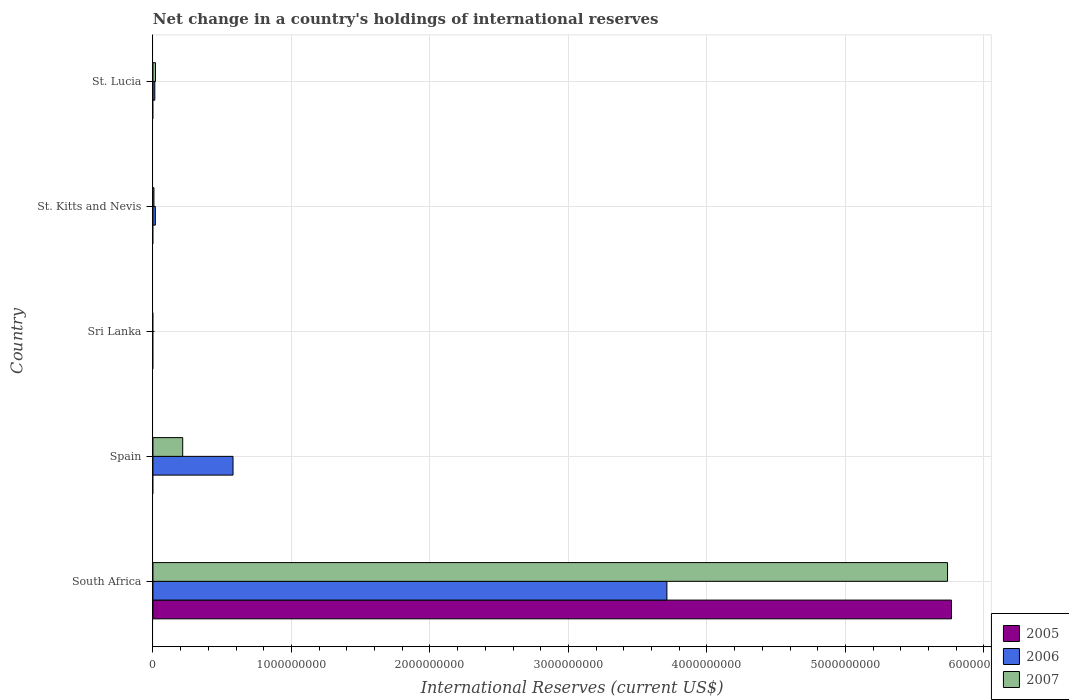How many different coloured bars are there?
Make the answer very short. 3. Are the number of bars per tick equal to the number of legend labels?
Keep it short and to the point. No. What is the label of the 5th group of bars from the top?
Ensure brevity in your answer.  South Africa. In how many cases, is the number of bars for a given country not equal to the number of legend labels?
Offer a terse response. 4. What is the international reserves in 2005 in St. Lucia?
Give a very brief answer. 0. Across all countries, what is the maximum international reserves in 2006?
Provide a succinct answer. 3.71e+09. In which country was the international reserves in 2006 maximum?
Provide a short and direct response. South Africa. What is the total international reserves in 2007 in the graph?
Offer a very short reply. 5.98e+09. What is the difference between the international reserves in 2006 in South Africa and that in St. Lucia?
Give a very brief answer. 3.70e+09. What is the difference between the international reserves in 2006 in South Africa and the international reserves in 2005 in St. Lucia?
Provide a short and direct response. 3.71e+09. What is the average international reserves in 2007 per country?
Your answer should be very brief. 1.20e+09. What is the difference between the international reserves in 2007 and international reserves in 2006 in South Africa?
Your response must be concise. 2.03e+09. In how many countries, is the international reserves in 2007 greater than 800000000 US$?
Offer a very short reply. 1. What is the ratio of the international reserves in 2006 in South Africa to that in St. Kitts and Nevis?
Your answer should be compact. 216.4. Is the difference between the international reserves in 2007 in South Africa and St. Kitts and Nevis greater than the difference between the international reserves in 2006 in South Africa and St. Kitts and Nevis?
Give a very brief answer. Yes. What is the difference between the highest and the second highest international reserves in 2006?
Your response must be concise. 3.13e+09. What is the difference between the highest and the lowest international reserves in 2006?
Make the answer very short. 3.71e+09. Is it the case that in every country, the sum of the international reserves in 2005 and international reserves in 2007 is greater than the international reserves in 2006?
Your response must be concise. No. Are all the bars in the graph horizontal?
Your answer should be very brief. Yes. How many countries are there in the graph?
Offer a terse response. 5. Are the values on the major ticks of X-axis written in scientific E-notation?
Provide a short and direct response. No. Where does the legend appear in the graph?
Give a very brief answer. Bottom right. How many legend labels are there?
Your answer should be compact. 3. How are the legend labels stacked?
Keep it short and to the point. Vertical. What is the title of the graph?
Provide a succinct answer. Net change in a country's holdings of international reserves. What is the label or title of the X-axis?
Your answer should be compact. International Reserves (current US$). What is the International Reserves (current US$) of 2005 in South Africa?
Your answer should be compact. 5.77e+09. What is the International Reserves (current US$) in 2006 in South Africa?
Make the answer very short. 3.71e+09. What is the International Reserves (current US$) of 2007 in South Africa?
Offer a very short reply. 5.74e+09. What is the International Reserves (current US$) of 2006 in Spain?
Provide a succinct answer. 5.78e+08. What is the International Reserves (current US$) of 2007 in Spain?
Your answer should be compact. 2.15e+08. What is the International Reserves (current US$) in 2006 in Sri Lanka?
Your answer should be compact. 0. What is the International Reserves (current US$) of 2007 in Sri Lanka?
Ensure brevity in your answer.  0. What is the International Reserves (current US$) of 2005 in St. Kitts and Nevis?
Make the answer very short. 0. What is the International Reserves (current US$) of 2006 in St. Kitts and Nevis?
Keep it short and to the point. 1.71e+07. What is the International Reserves (current US$) of 2007 in St. Kitts and Nevis?
Ensure brevity in your answer.  7.18e+06. What is the International Reserves (current US$) in 2006 in St. Lucia?
Offer a terse response. 1.35e+07. What is the International Reserves (current US$) in 2007 in St. Lucia?
Make the answer very short. 1.86e+07. Across all countries, what is the maximum International Reserves (current US$) of 2005?
Your response must be concise. 5.77e+09. Across all countries, what is the maximum International Reserves (current US$) in 2006?
Make the answer very short. 3.71e+09. Across all countries, what is the maximum International Reserves (current US$) of 2007?
Offer a very short reply. 5.74e+09. Across all countries, what is the minimum International Reserves (current US$) in 2005?
Offer a terse response. 0. What is the total International Reserves (current US$) of 2005 in the graph?
Provide a short and direct response. 5.77e+09. What is the total International Reserves (current US$) in 2006 in the graph?
Your response must be concise. 4.32e+09. What is the total International Reserves (current US$) in 2007 in the graph?
Give a very brief answer. 5.98e+09. What is the difference between the International Reserves (current US$) of 2006 in South Africa and that in Spain?
Keep it short and to the point. 3.13e+09. What is the difference between the International Reserves (current US$) of 2007 in South Africa and that in Spain?
Ensure brevity in your answer.  5.52e+09. What is the difference between the International Reserves (current US$) in 2006 in South Africa and that in St. Kitts and Nevis?
Your answer should be compact. 3.69e+09. What is the difference between the International Reserves (current US$) in 2007 in South Africa and that in St. Kitts and Nevis?
Provide a short and direct response. 5.73e+09. What is the difference between the International Reserves (current US$) in 2006 in South Africa and that in St. Lucia?
Your answer should be compact. 3.70e+09. What is the difference between the International Reserves (current US$) in 2007 in South Africa and that in St. Lucia?
Your answer should be very brief. 5.72e+09. What is the difference between the International Reserves (current US$) of 2006 in Spain and that in St. Kitts and Nevis?
Offer a very short reply. 5.61e+08. What is the difference between the International Reserves (current US$) of 2007 in Spain and that in St. Kitts and Nevis?
Your answer should be compact. 2.08e+08. What is the difference between the International Reserves (current US$) of 2006 in Spain and that in St. Lucia?
Your response must be concise. 5.65e+08. What is the difference between the International Reserves (current US$) in 2007 in Spain and that in St. Lucia?
Make the answer very short. 1.96e+08. What is the difference between the International Reserves (current US$) of 2006 in St. Kitts and Nevis and that in St. Lucia?
Your answer should be very brief. 3.67e+06. What is the difference between the International Reserves (current US$) of 2007 in St. Kitts and Nevis and that in St. Lucia?
Offer a very short reply. -1.14e+07. What is the difference between the International Reserves (current US$) of 2005 in South Africa and the International Reserves (current US$) of 2006 in Spain?
Keep it short and to the point. 5.19e+09. What is the difference between the International Reserves (current US$) of 2005 in South Africa and the International Reserves (current US$) of 2007 in Spain?
Keep it short and to the point. 5.55e+09. What is the difference between the International Reserves (current US$) in 2006 in South Africa and the International Reserves (current US$) in 2007 in Spain?
Offer a very short reply. 3.50e+09. What is the difference between the International Reserves (current US$) in 2005 in South Africa and the International Reserves (current US$) in 2006 in St. Kitts and Nevis?
Provide a short and direct response. 5.75e+09. What is the difference between the International Reserves (current US$) of 2005 in South Africa and the International Reserves (current US$) of 2007 in St. Kitts and Nevis?
Ensure brevity in your answer.  5.76e+09. What is the difference between the International Reserves (current US$) of 2006 in South Africa and the International Reserves (current US$) of 2007 in St. Kitts and Nevis?
Your answer should be compact. 3.70e+09. What is the difference between the International Reserves (current US$) of 2005 in South Africa and the International Reserves (current US$) of 2006 in St. Lucia?
Provide a short and direct response. 5.75e+09. What is the difference between the International Reserves (current US$) in 2005 in South Africa and the International Reserves (current US$) in 2007 in St. Lucia?
Keep it short and to the point. 5.75e+09. What is the difference between the International Reserves (current US$) of 2006 in South Africa and the International Reserves (current US$) of 2007 in St. Lucia?
Your answer should be compact. 3.69e+09. What is the difference between the International Reserves (current US$) of 2006 in Spain and the International Reserves (current US$) of 2007 in St. Kitts and Nevis?
Your response must be concise. 5.71e+08. What is the difference between the International Reserves (current US$) of 2006 in Spain and the International Reserves (current US$) of 2007 in St. Lucia?
Give a very brief answer. 5.60e+08. What is the difference between the International Reserves (current US$) in 2006 in St. Kitts and Nevis and the International Reserves (current US$) in 2007 in St. Lucia?
Ensure brevity in your answer.  -1.43e+06. What is the average International Reserves (current US$) of 2005 per country?
Offer a very short reply. 1.15e+09. What is the average International Reserves (current US$) of 2006 per country?
Provide a succinct answer. 8.64e+08. What is the average International Reserves (current US$) in 2007 per country?
Ensure brevity in your answer.  1.20e+09. What is the difference between the International Reserves (current US$) in 2005 and International Reserves (current US$) in 2006 in South Africa?
Keep it short and to the point. 2.05e+09. What is the difference between the International Reserves (current US$) of 2005 and International Reserves (current US$) of 2007 in South Africa?
Provide a short and direct response. 2.86e+07. What is the difference between the International Reserves (current US$) of 2006 and International Reserves (current US$) of 2007 in South Africa?
Make the answer very short. -2.03e+09. What is the difference between the International Reserves (current US$) of 2006 and International Reserves (current US$) of 2007 in Spain?
Make the answer very short. 3.63e+08. What is the difference between the International Reserves (current US$) of 2006 and International Reserves (current US$) of 2007 in St. Kitts and Nevis?
Offer a terse response. 9.97e+06. What is the difference between the International Reserves (current US$) of 2006 and International Reserves (current US$) of 2007 in St. Lucia?
Your response must be concise. -5.10e+06. What is the ratio of the International Reserves (current US$) of 2006 in South Africa to that in Spain?
Keep it short and to the point. 6.42. What is the ratio of the International Reserves (current US$) of 2007 in South Africa to that in Spain?
Offer a very short reply. 26.7. What is the ratio of the International Reserves (current US$) of 2006 in South Africa to that in St. Kitts and Nevis?
Keep it short and to the point. 216.4. What is the ratio of the International Reserves (current US$) in 2007 in South Africa to that in St. Kitts and Nevis?
Offer a terse response. 798.8. What is the ratio of the International Reserves (current US$) of 2006 in South Africa to that in St. Lucia?
Your response must be concise. 275.4. What is the ratio of the International Reserves (current US$) of 2007 in South Africa to that in St. Lucia?
Offer a terse response. 308.86. What is the ratio of the International Reserves (current US$) of 2006 in Spain to that in St. Kitts and Nevis?
Ensure brevity in your answer.  33.72. What is the ratio of the International Reserves (current US$) in 2007 in Spain to that in St. Kitts and Nevis?
Provide a succinct answer. 29.92. What is the ratio of the International Reserves (current US$) of 2006 in Spain to that in St. Lucia?
Provide a succinct answer. 42.91. What is the ratio of the International Reserves (current US$) of 2007 in Spain to that in St. Lucia?
Make the answer very short. 11.57. What is the ratio of the International Reserves (current US$) of 2006 in St. Kitts and Nevis to that in St. Lucia?
Your answer should be compact. 1.27. What is the ratio of the International Reserves (current US$) of 2007 in St. Kitts and Nevis to that in St. Lucia?
Your answer should be compact. 0.39. What is the difference between the highest and the second highest International Reserves (current US$) of 2006?
Provide a succinct answer. 3.13e+09. What is the difference between the highest and the second highest International Reserves (current US$) of 2007?
Make the answer very short. 5.52e+09. What is the difference between the highest and the lowest International Reserves (current US$) of 2005?
Keep it short and to the point. 5.77e+09. What is the difference between the highest and the lowest International Reserves (current US$) in 2006?
Offer a very short reply. 3.71e+09. What is the difference between the highest and the lowest International Reserves (current US$) in 2007?
Provide a short and direct response. 5.74e+09. 